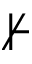Convert formula to latex. <formula><loc_0><loc_0><loc_500><loc_500>\nvdash</formula> 